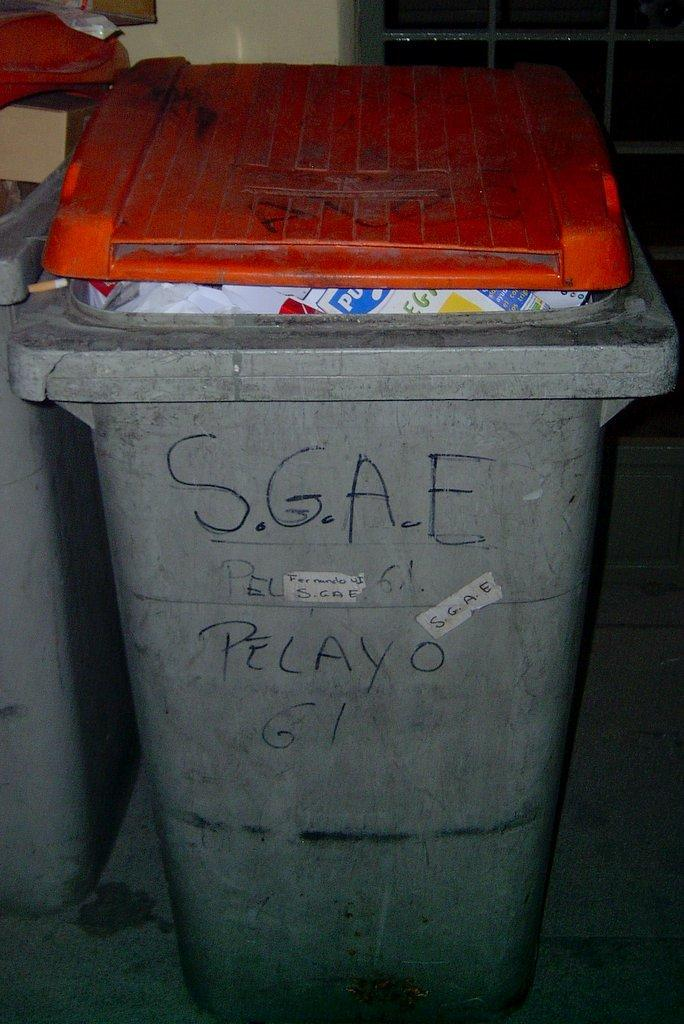<image>
Give a short and clear explanation of the subsequent image. A grey bin with S.G.A.E written on the front of it. 